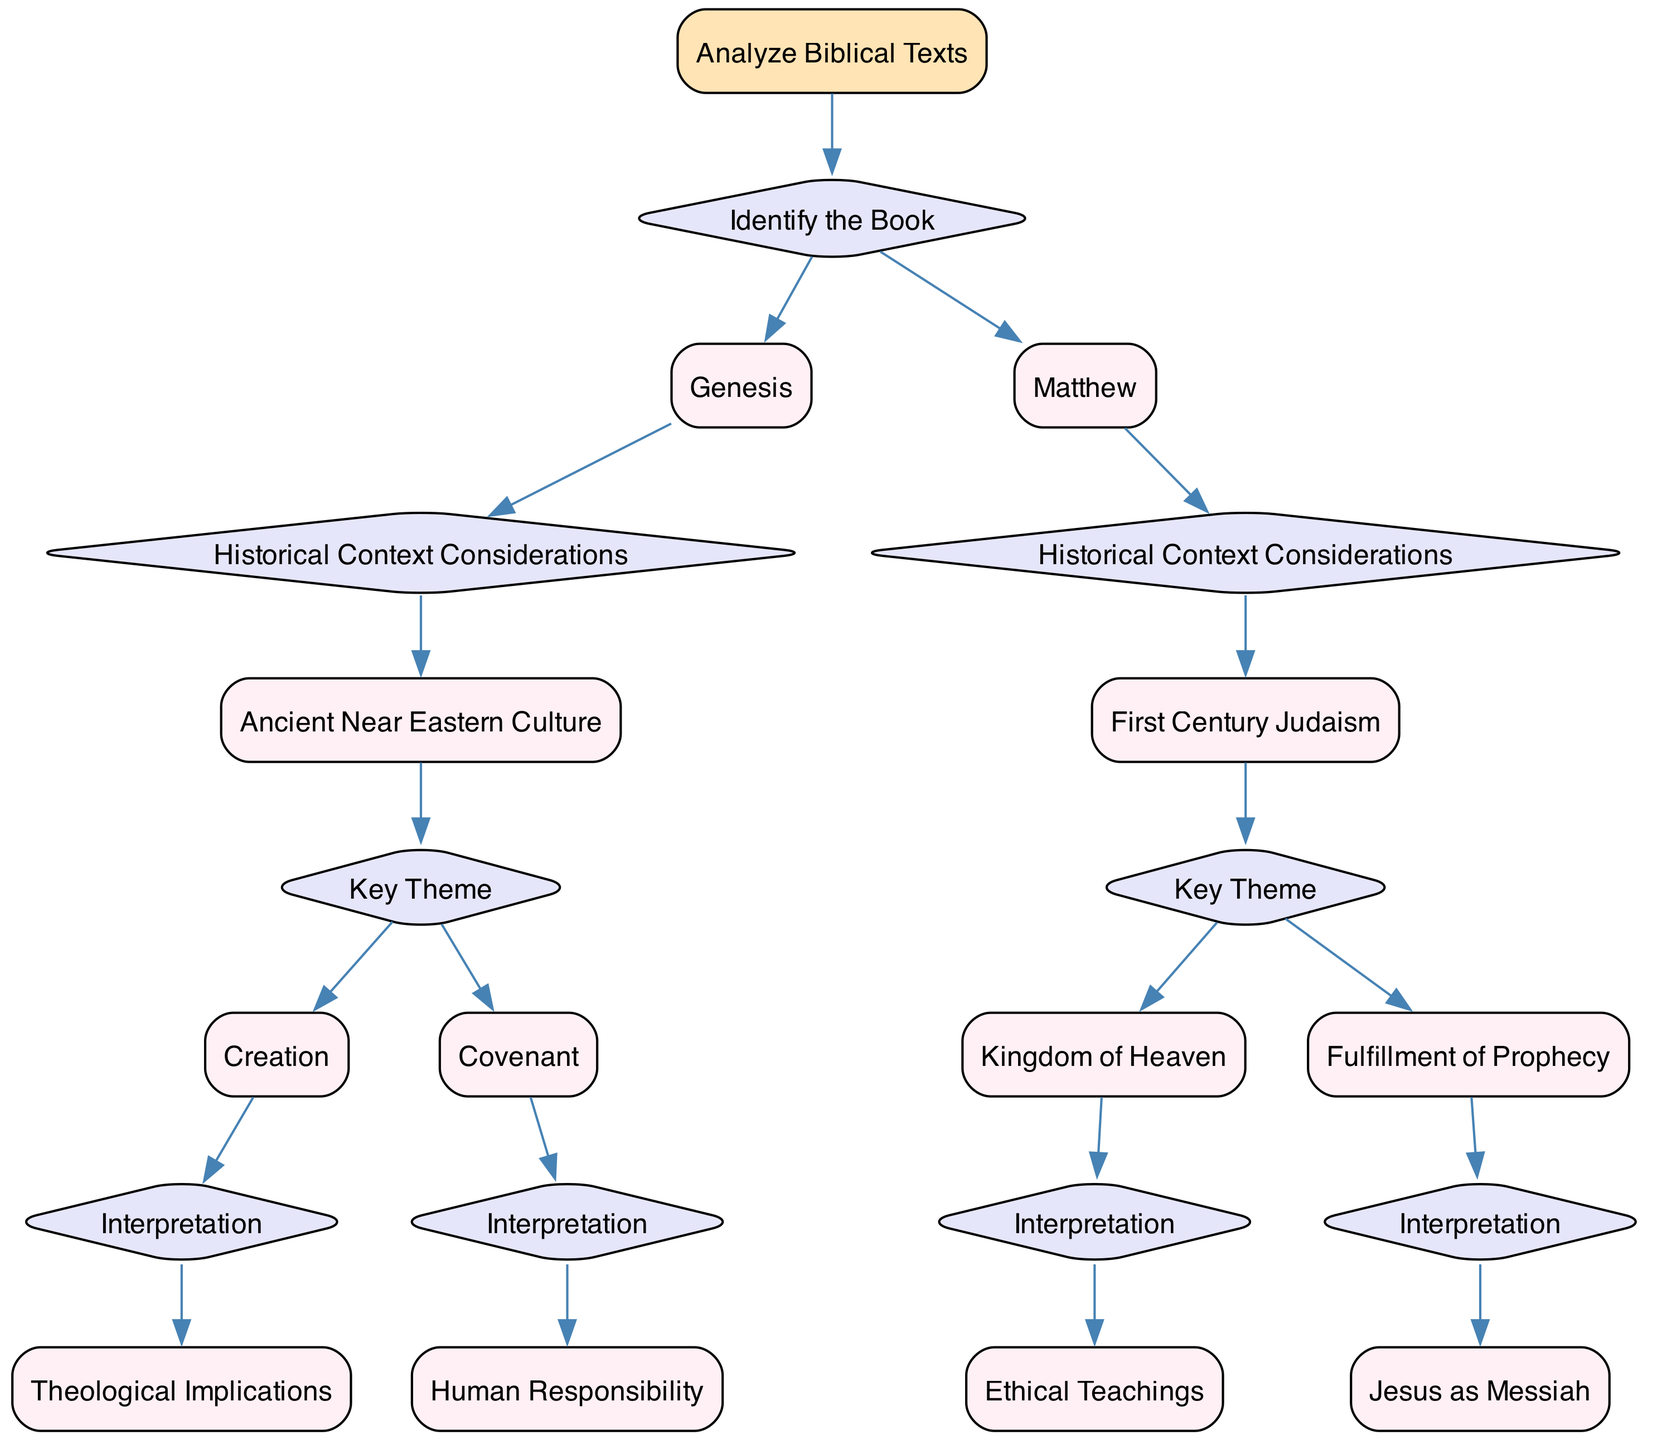What is the root of the decision tree? The root node is the starting point of the decision tree, which is labeled "Analyze Biblical Texts."
Answer: Analyze Biblical Texts How many branches does the root have? The root has two main branches that represent the options for identifying biblical books (Genesis and Matthew).
Answer: 2 What is the key theme for the Book of Genesis? The diagram outlines two key themes for Genesis: "Creation" and "Covenant."
Answer: Creation, Covenant What historical context is associated with the Book of Matthew? The historical context associated with the Book of Matthew is "First Century Judaism."
Answer: First Century Judaism What conclusion is reached when analyzing the theme of "Fulfillment of Prophecy"? The final conclusion drawn from analyzing "Fulfillment of Prophecy" leads to understanding "Jesus as Messiah."
Answer: Understanding Jesus' Role What are the two key themes under the historical context of Ancient Near Eastern Culture? The two key themes under this context are "Creation" and "Covenant."
Answer: Creation, Covenant What is the interpretation derived from the key theme "Kingdom of Heaven"? The interpretation from the key theme "Kingdom of Heaven" focuses on "Ethical Teachings."
Answer: Ethical Teachings What type of node is "Historical Context Considerations"? The node labeled "Historical Context Considerations" is a question node, shaped like a diamond.
Answer: Question node What is the conclusion for the theme of "Covenant"? The conclusion reached from the theme of "Covenant" is "God's Promise to Humanity."
Answer: God's Promise to Humanity 